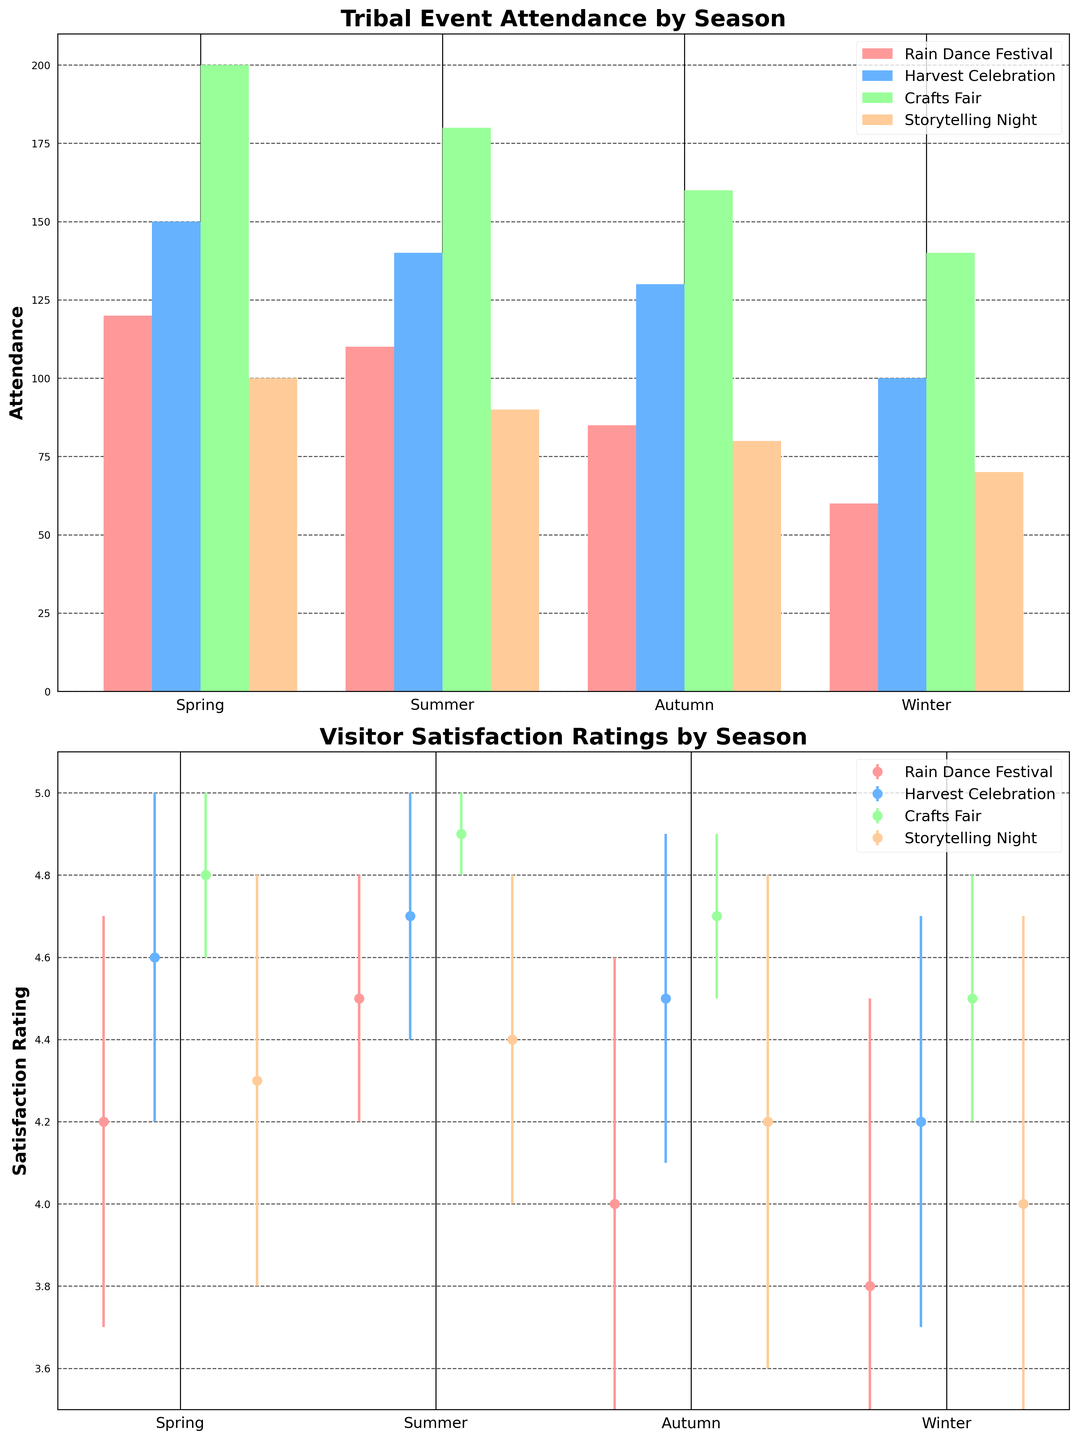What's the title of the first subplot? The title of the first subplot is given at the top of the first set of bars in the figure.
Answer: Tribal Event Attendance by Season Which season has the lowest attendance for the Rain Dance Festival? Looking at the first subplot, identify the lowest bar for the Rain Dance Festival entries (color-coded). For the Rain Dance Festival, the lowest bar appears in Winter.
Answer: Winter What's the mean satisfaction rating for the Harvest Celebration in Spring? Refer to the second subplot and focus on the data points for the Harvest Celebration in Spring. The point and accompanying error bar will show the mean value.
Answer: 4.7 Compare the attendance of the Crafts Fair in Summer and Autumn. Which season has higher attendance? In the first subplot, note the heights of the bars for the Crafts Fair (color-coded) for both Summer and Autumn. The Summer attendance bar is higher than the Autumn one.
Answer: Summer For the Storytelling Night event, what's the difference in attendance between Spring and Winter? In the first subplot, measure the height of the bars for Storytelling Night in Spring and Winter, then subtract the Winter value from the Spring value (90 - 70).
Answer: 20 Which event has the highest visitor satisfaction rating in Summer? Examine the second subplot data points for all events in Summer and identify the highest point. The Crafts Fair has the highest rating.
Answer: Crafts Fair What’s the average satisfaction rating for the Rain Dance Festival across all seasons? For the second subplot, sum up the mean satisfaction ratings of the Rain Dance Festival over all seasons (4.2 + 4.5 + 4.0 + 3.8) and divide by the number of seasons.
Answer: 4.125 Which season shows the highest average satisfaction rating overall? For the second subplot, calculate the average satisfaction rating of all events for each season. The highest average satisfaction rating will come from summing the ratings for all events per season and averaging them; Summer turns out to have the highest.
Answer: Summer Is there a significant variation in visitor satisfaction ratings for the Storytelling Night event? In the second subplot, look at the error bars (standard deviation) for Storytelling Night across all seasons. Longer error bars denote higher variation. Storytelling Night shows significant variation as the error bars are relatively long.
Answer: Yes How does the attendance for the Rain Dance Festival compare between Summer and Autumn? Compare the heights of the bars for the Rain Dance Festival in Summer and Autumn in the first subplot. The Summer attendance (120) is higher than the Autumn attendance (85).
Answer: Summer has higher attendance 